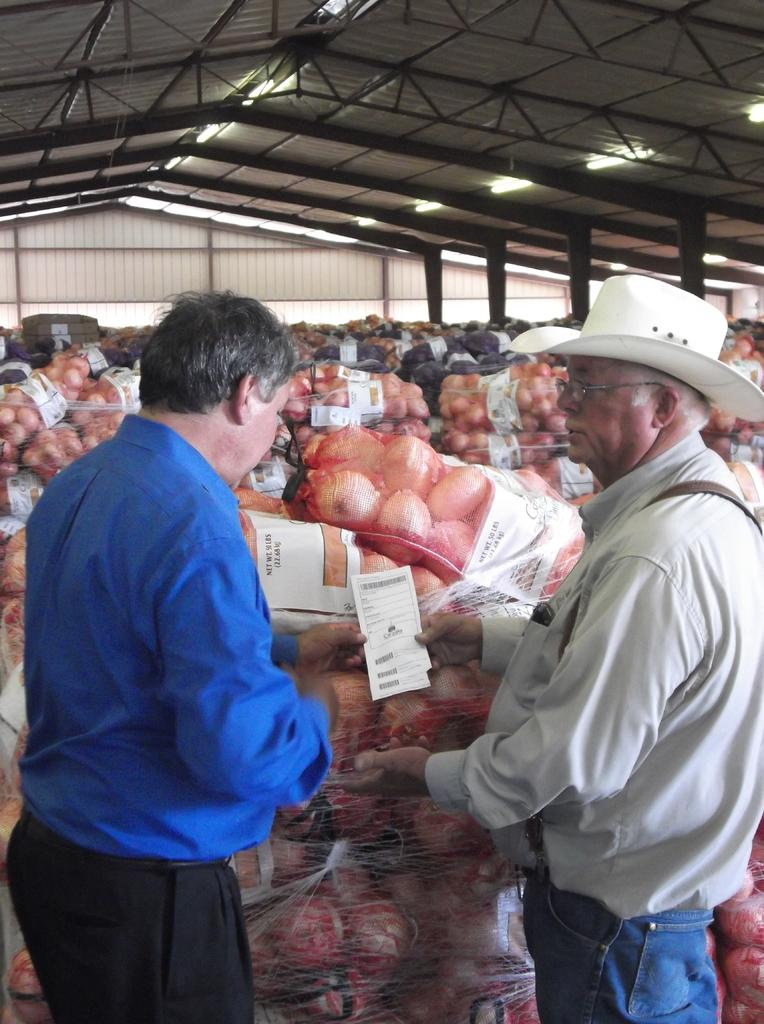How many people are present in the image? There are two men standing in the image. What are the men doing in the image? The information provided does not specify what the men are doing. What can be seen inside the bags in the image? There are objects placed in bags in the image. What type of structure is visible at the top of the image? There is a shed visible at the top of the image. How many children are visiting the shed in the image? There is no information about children or a visit to the shed in the image. 